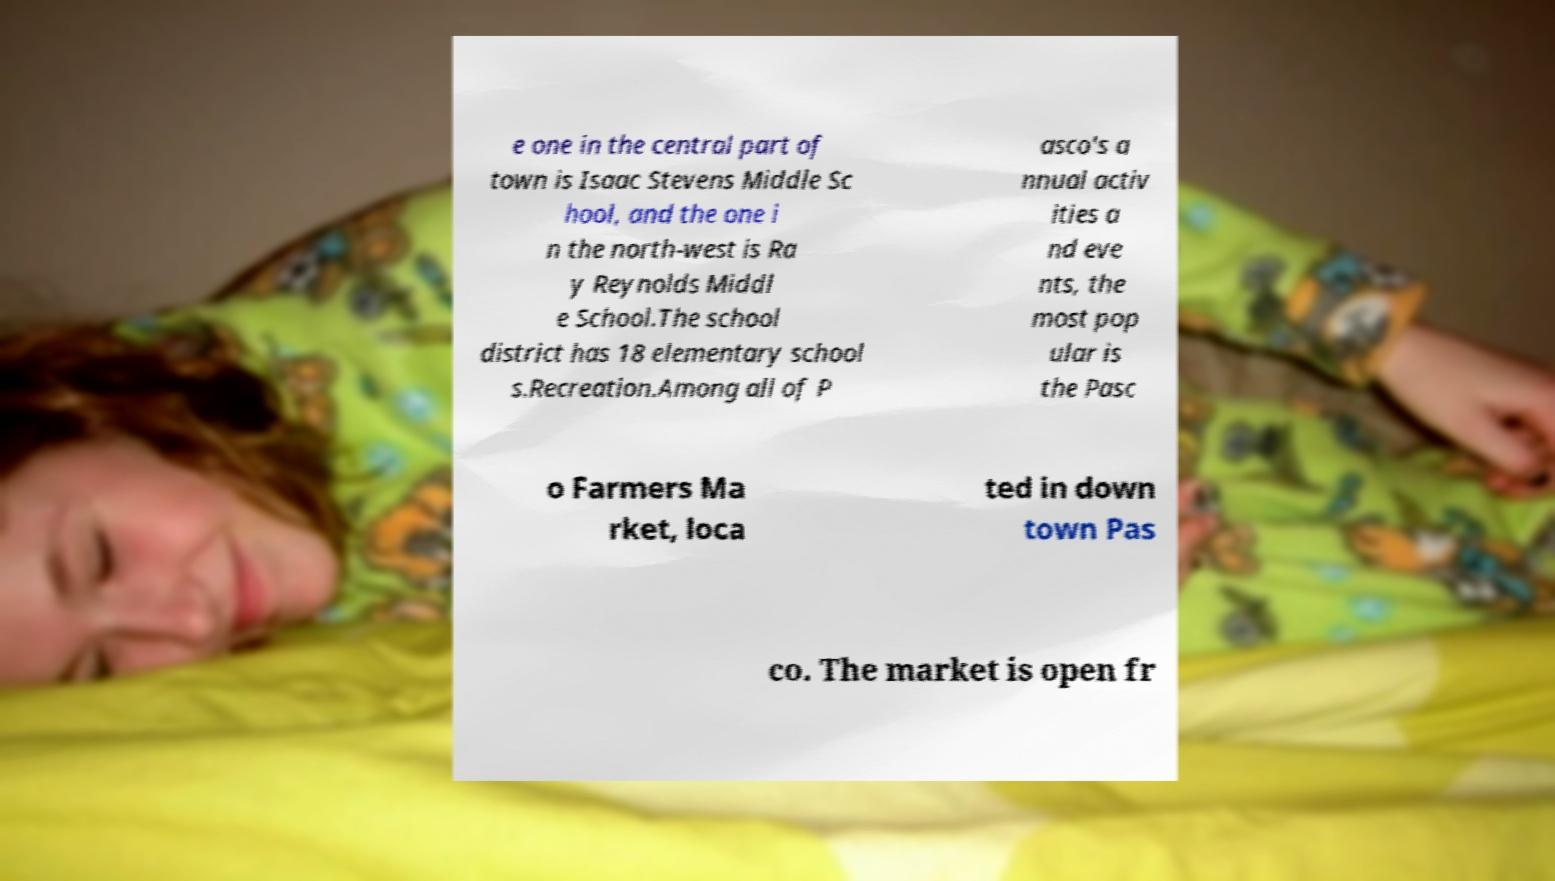Can you read and provide the text displayed in the image?This photo seems to have some interesting text. Can you extract and type it out for me? e one in the central part of town is Isaac Stevens Middle Sc hool, and the one i n the north-west is Ra y Reynolds Middl e School.The school district has 18 elementary school s.Recreation.Among all of P asco's a nnual activ ities a nd eve nts, the most pop ular is the Pasc o Farmers Ma rket, loca ted in down town Pas co. The market is open fr 